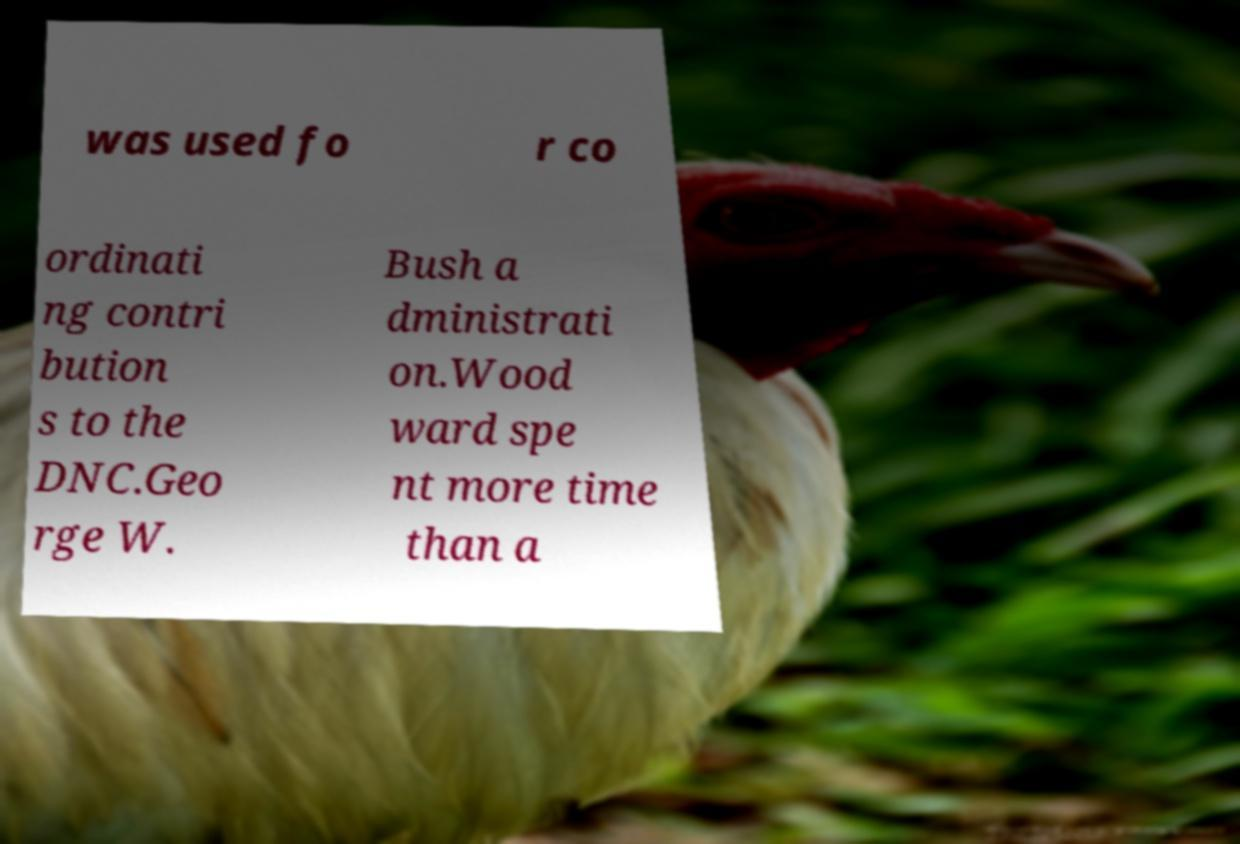Please identify and transcribe the text found in this image. was used fo r co ordinati ng contri bution s to the DNC.Geo rge W. Bush a dministrati on.Wood ward spe nt more time than a 